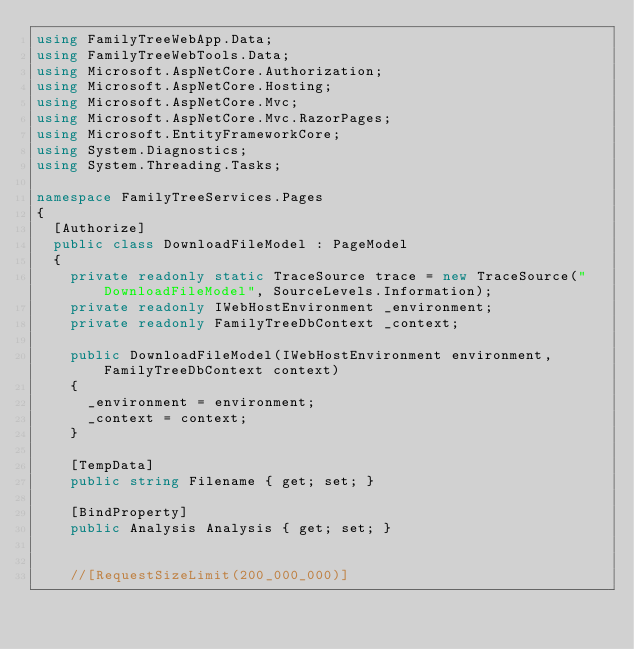<code> <loc_0><loc_0><loc_500><loc_500><_C#_>using FamilyTreeWebApp.Data;
using FamilyTreeWebTools.Data;
using Microsoft.AspNetCore.Authorization;
using Microsoft.AspNetCore.Hosting;
using Microsoft.AspNetCore.Mvc;
using Microsoft.AspNetCore.Mvc.RazorPages;
using Microsoft.EntityFrameworkCore;
using System.Diagnostics;
using System.Threading.Tasks;

namespace FamilyTreeServices.Pages
{
  [Authorize]
  public class DownloadFileModel : PageModel
  {
    private readonly static TraceSource trace = new TraceSource("DownloadFileModel", SourceLevels.Information);
    private readonly IWebHostEnvironment _environment;
    private readonly FamilyTreeDbContext _context;

    public DownloadFileModel(IWebHostEnvironment environment, FamilyTreeDbContext context)
    {
      _environment = environment;
      _context = context;
    }

    [TempData]
    public string Filename { get; set; }

    [BindProperty]
    public Analysis Analysis { get; set; }


    //[RequestSizeLimit(200_000_000)]</code> 